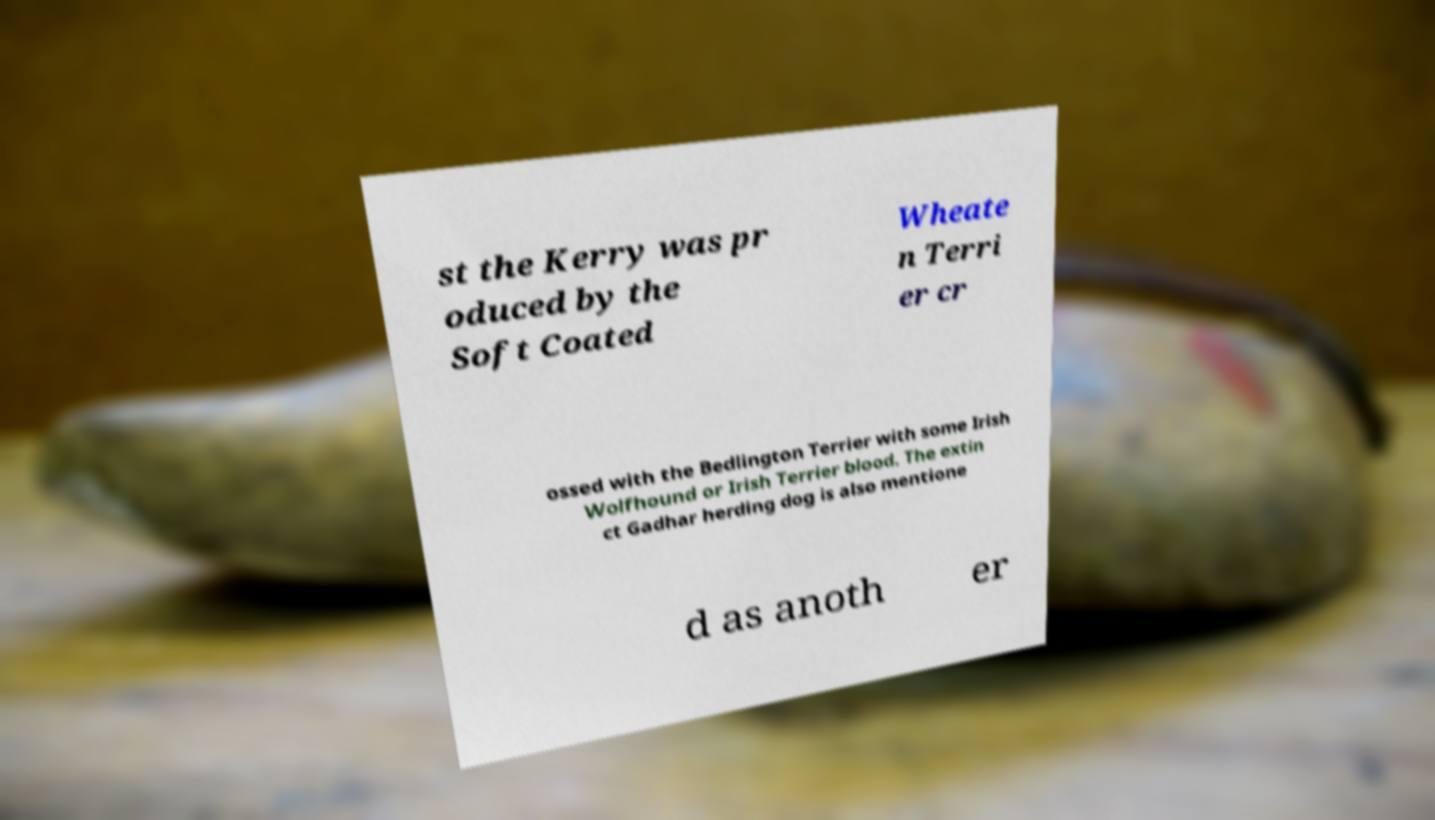Can you read and provide the text displayed in the image?This photo seems to have some interesting text. Can you extract and type it out for me? st the Kerry was pr oduced by the Soft Coated Wheate n Terri er cr ossed with the Bedlington Terrier with some Irish Wolfhound or Irish Terrier blood. The extin ct Gadhar herding dog is also mentione d as anoth er 